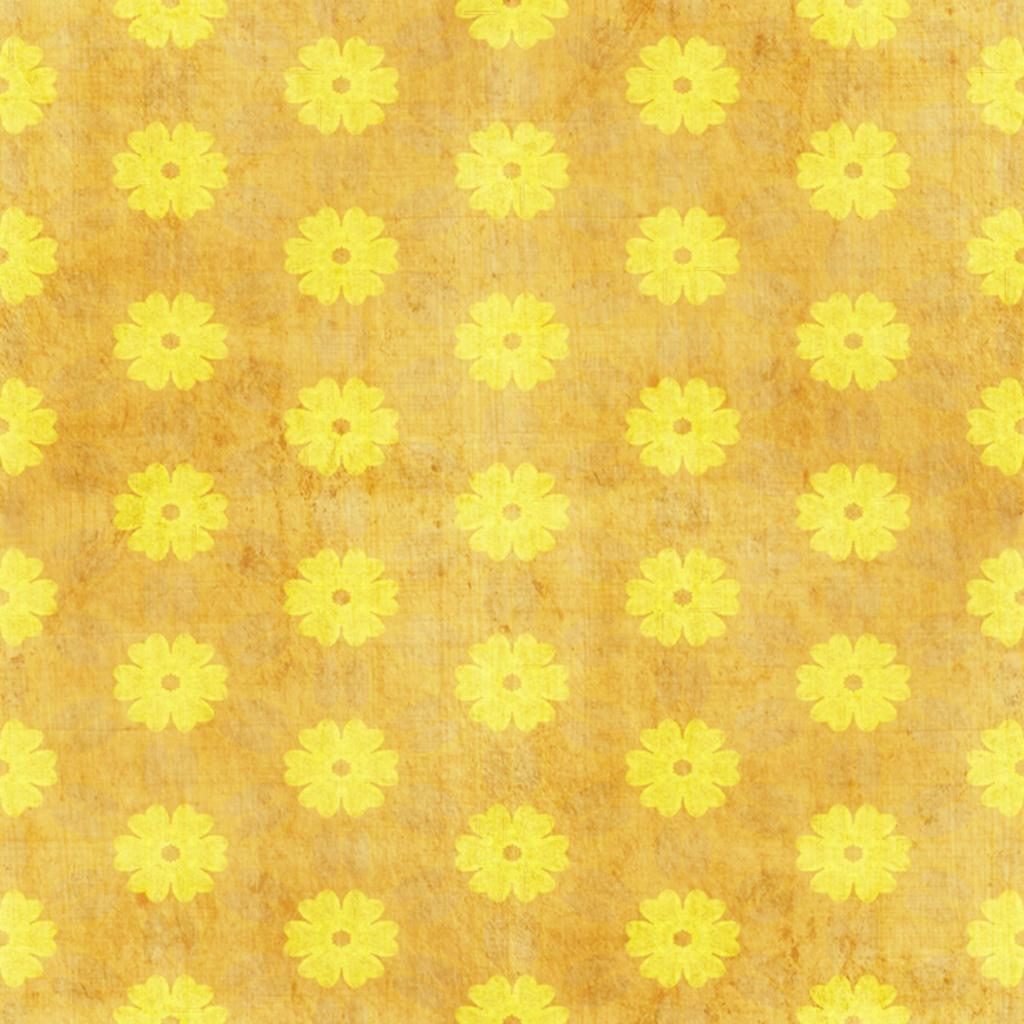What is the medium of the image? The image appears to be on paper. What is the main subject of the image? There are many flowers in the image. What color are the flowers in the image? The flowers are in yellow color. Where is the shelf with the feast located in the image? There is no shelf or feast present in the image; it only features yellow flowers. What type of mitten is being used to hold the flowers in the image? There is no mitten present in the image; the flowers are not being held by any object or person. 